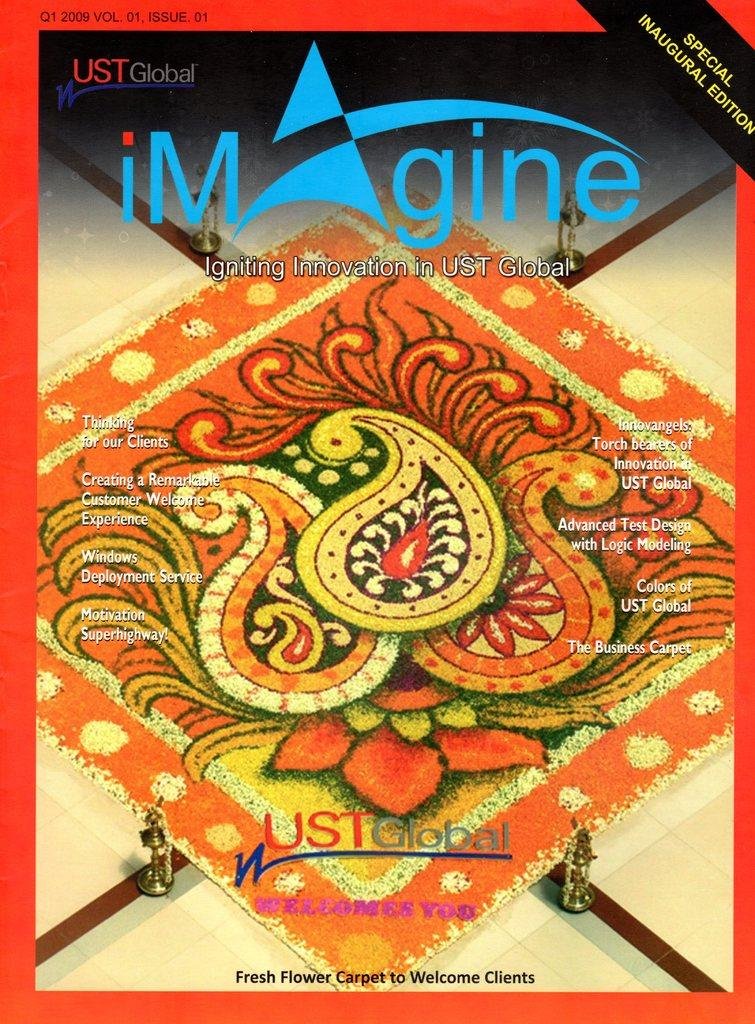<image>
Describe the image concisely. The special edition UST Global magazine cover entitled Imagine. 